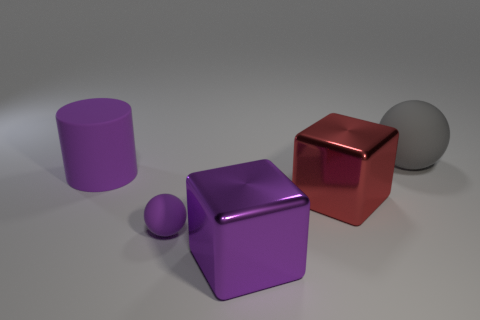There is a rubber sphere in front of the big cylinder; is its color the same as the cylinder?
Provide a short and direct response. Yes. What is the shape of the red object that is the same size as the gray matte ball?
Your answer should be compact. Cube. The large gray rubber thing is what shape?
Provide a short and direct response. Sphere. Do the big purple object that is on the left side of the purple block and the large purple cube have the same material?
Provide a succinct answer. No. There is a purple matte object that is behind the rubber ball that is on the left side of the large red metallic thing; what size is it?
Make the answer very short. Large. What color is the matte thing that is right of the large purple rubber cylinder and to the left of the purple cube?
Provide a succinct answer. Purple. There is a red block that is the same size as the purple cylinder; what material is it?
Provide a short and direct response. Metal. How many other things are made of the same material as the red thing?
Provide a short and direct response. 1. There is a large object that is to the left of the big purple metallic object; is it the same color as the ball in front of the red shiny thing?
Your response must be concise. Yes. There is a metal object in front of the purple rubber thing in front of the cylinder; what is its shape?
Ensure brevity in your answer.  Cube. 